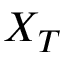<formula> <loc_0><loc_0><loc_500><loc_500>X _ { T }</formula> 